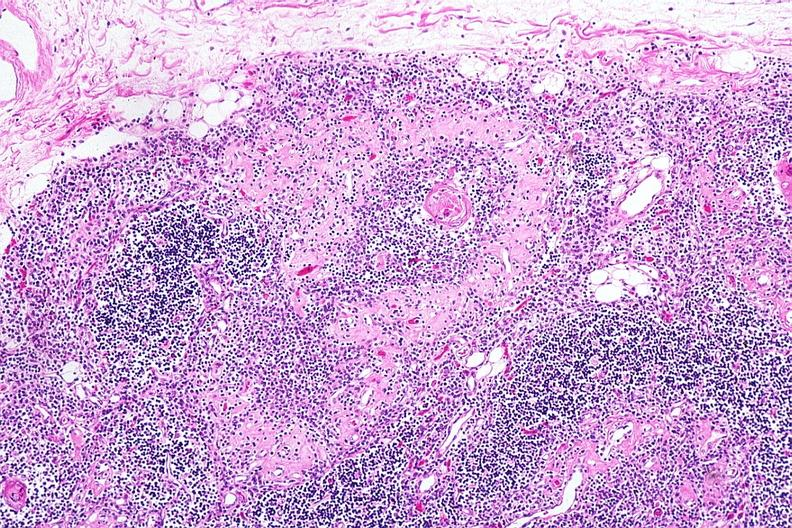s lesion present?
Answer the question using a single word or phrase. No 